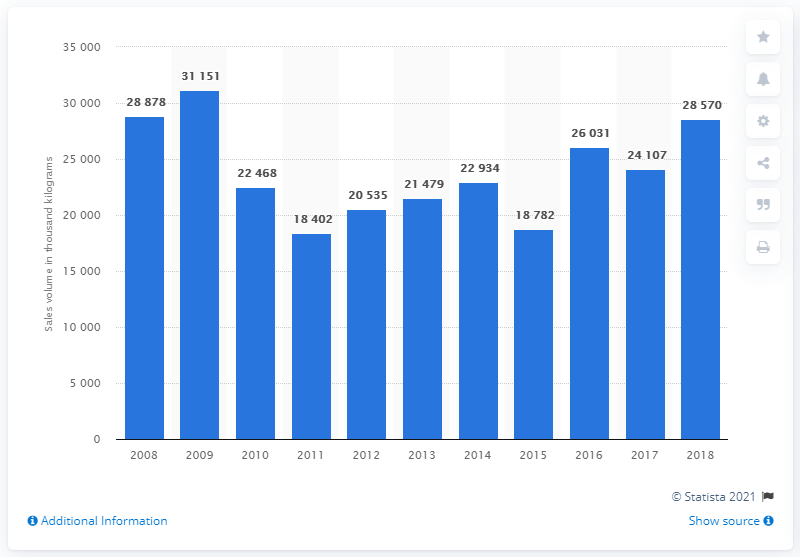How does the sales volume in 2014 compare to the next two years? In 2014, the sales volume was 21,479 thousand kilograms. It saw a slight increase in 2015 to 22,934 thousand kilograms and rose further in 2016 to 24,107 thousand kilograms. 